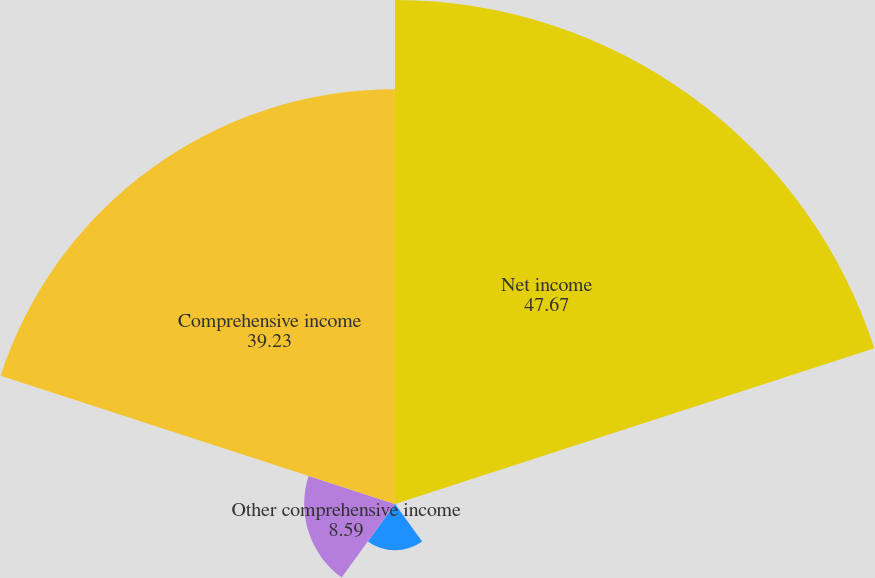Convert chart to OTSL. <chart><loc_0><loc_0><loc_500><loc_500><pie_chart><fcel>Net income<fcel>Unrealized gains (losses) on<fcel>Losses on interest rate swaps<fcel>Other comprehensive income<fcel>Comprehensive income<nl><fcel>47.67%<fcel>0.14%<fcel>4.37%<fcel>8.59%<fcel>39.23%<nl></chart> 